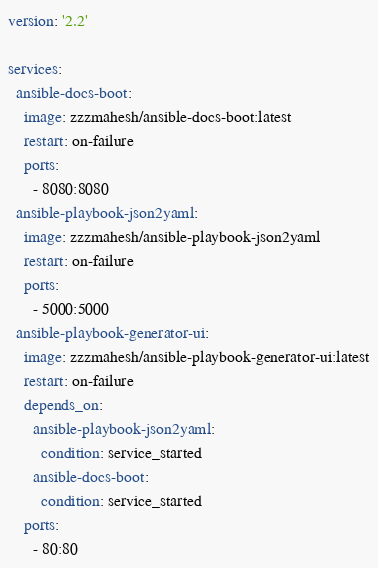<code> <loc_0><loc_0><loc_500><loc_500><_YAML_>version: '2.2'

services:
  ansible-docs-boot:
    image: zzzmahesh/ansible-docs-boot:latest
    restart: on-failure
    ports:
      - 8080:8080
  ansible-playbook-json2yaml:
    image: zzzmahesh/ansible-playbook-json2yaml
    restart: on-failure
    ports:
      - 5000:5000
  ansible-playbook-generator-ui:
    image: zzzmahesh/ansible-playbook-generator-ui:latest
    restart: on-failure
    depends_on:
      ansible-playbook-json2yaml:
        condition: service_started
      ansible-docs-boot:
        condition: service_started
    ports:
      - 80:80
</code> 